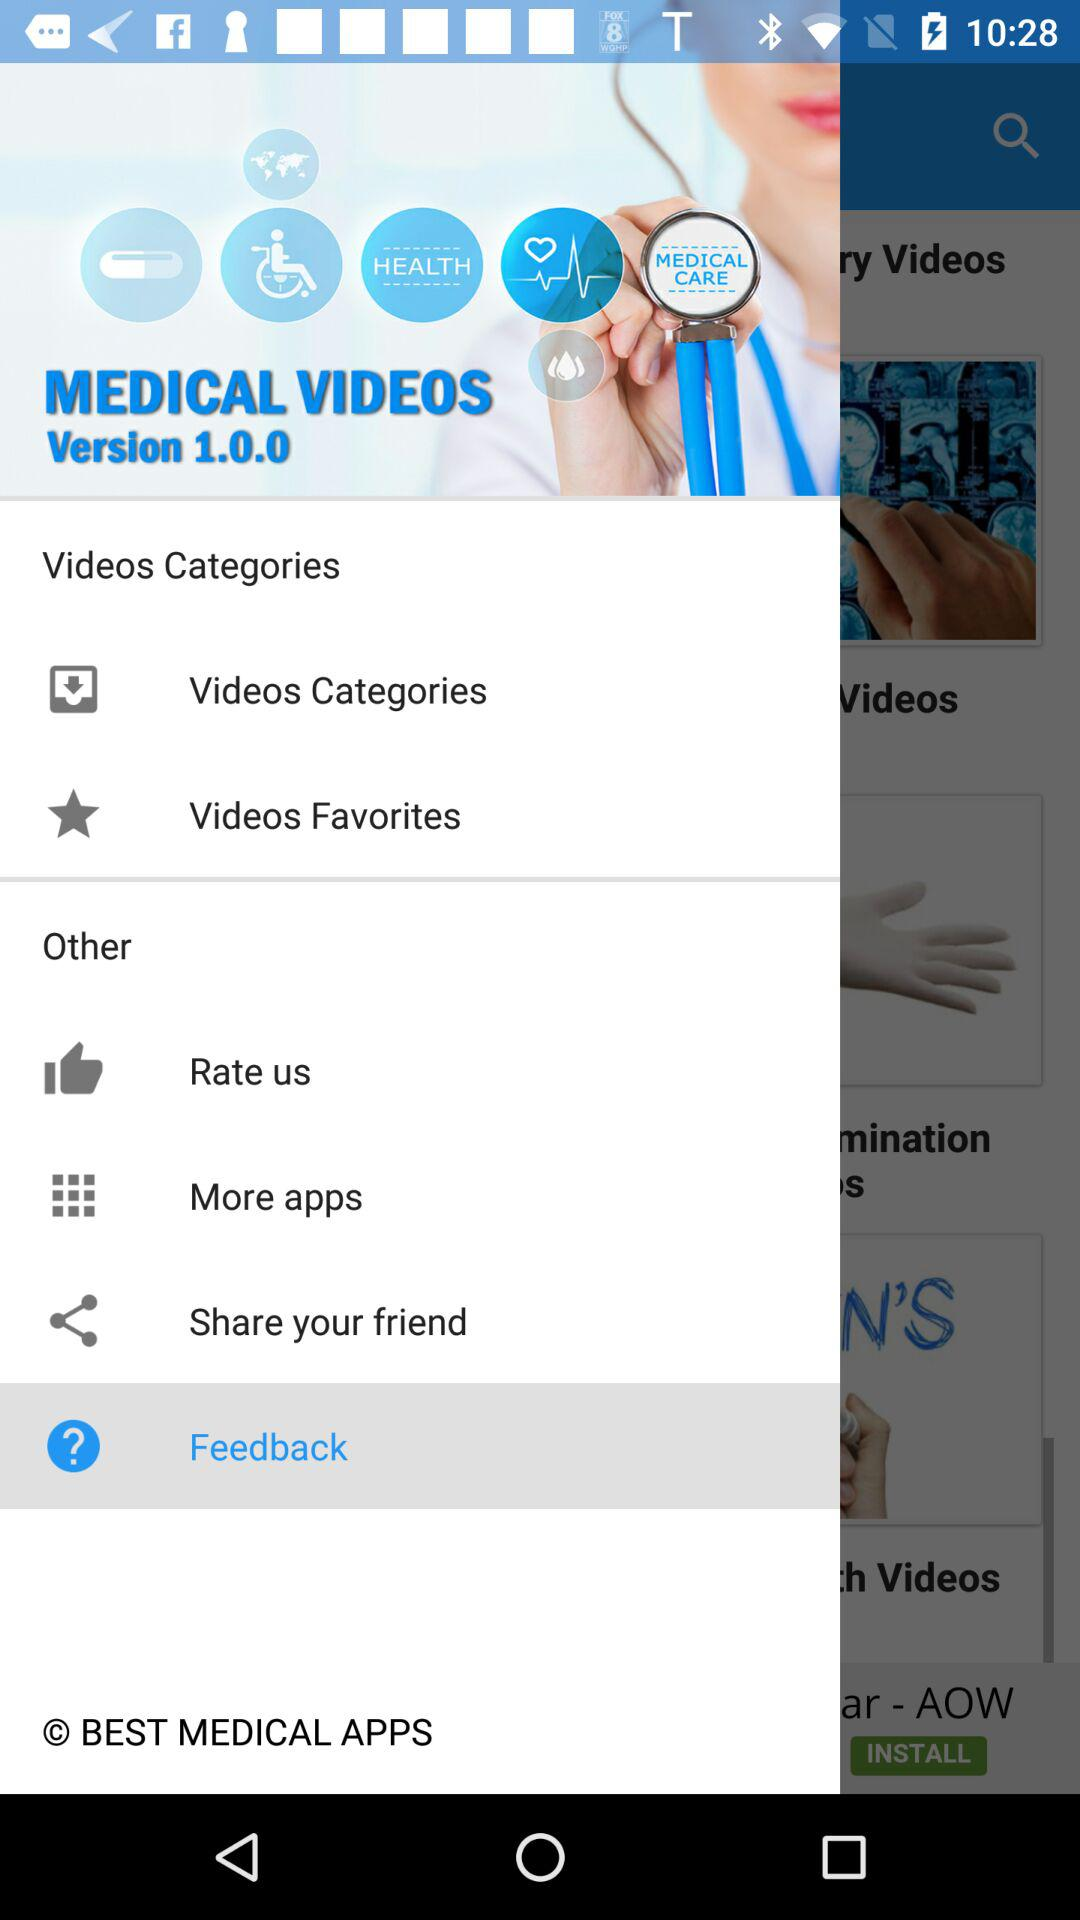Which is the selected option? The selected option is "Feedback". 